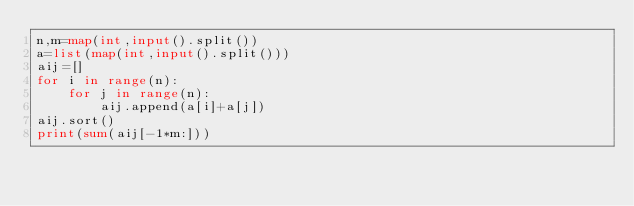Convert code to text. <code><loc_0><loc_0><loc_500><loc_500><_Python_>n,m=map(int,input().split())
a=list(map(int,input().split()))
aij=[]
for i in range(n):
    for j in range(n):
        aij.append(a[i]+a[j])
aij.sort()
print(sum(aij[-1*m:]))

</code> 